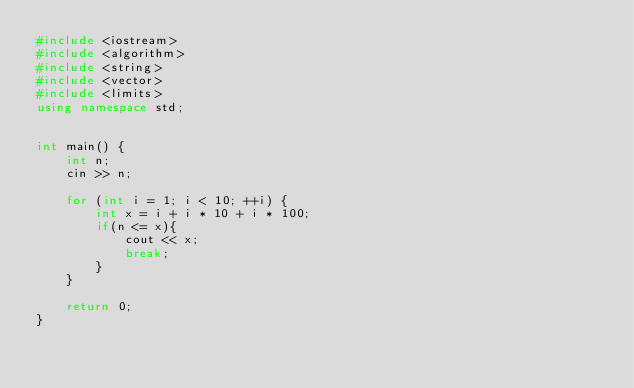<code> <loc_0><loc_0><loc_500><loc_500><_C++_>#include <iostream>
#include <algorithm>
#include <string>
#include <vector>
#include <limits>
using namespace std;


int main() {
    int n;
    cin >> n;

    for (int i = 1; i < 10; ++i) {
        int x = i + i * 10 + i * 100;
        if(n <= x){
            cout << x;
            break;
        }
    }

    return 0;
}
</code> 